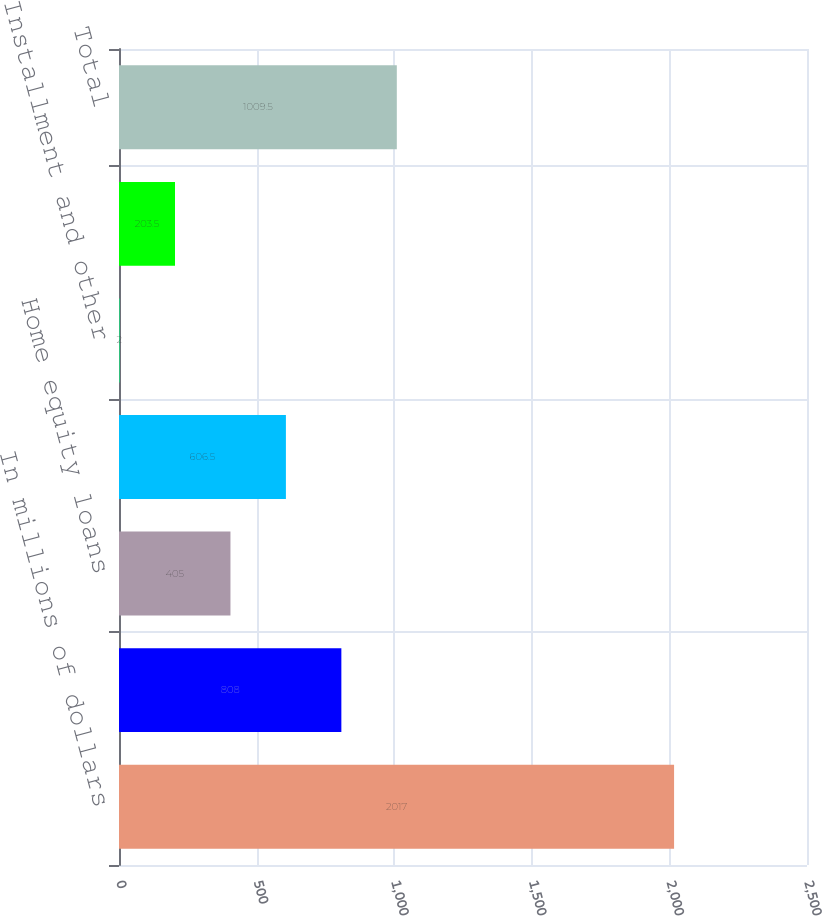Convert chart to OTSL. <chart><loc_0><loc_0><loc_500><loc_500><bar_chart><fcel>In millions of dollars<fcel>Residential first mortgages<fcel>Home equity loans<fcel>Credit cards<fcel>Installment and other<fcel>Commercial banking<fcel>Total<nl><fcel>2017<fcel>808<fcel>405<fcel>606.5<fcel>2<fcel>203.5<fcel>1009.5<nl></chart> 